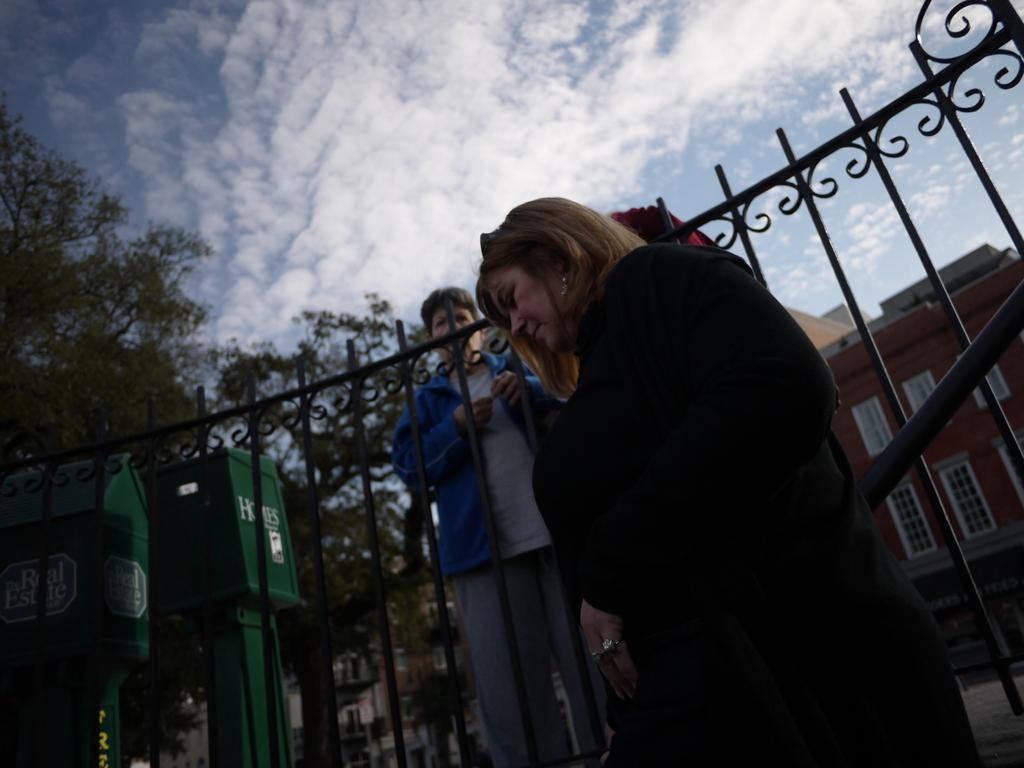Describe this image in one or two sentences. In this image in the center there is one woman standing, and there is a fence and some containers and one person is standing. In the background there are some trees and buildings, at the top there is sky. 